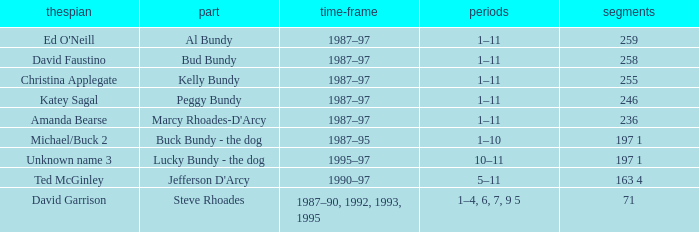How many episodes did the actor David Faustino appear in? 258.0. 